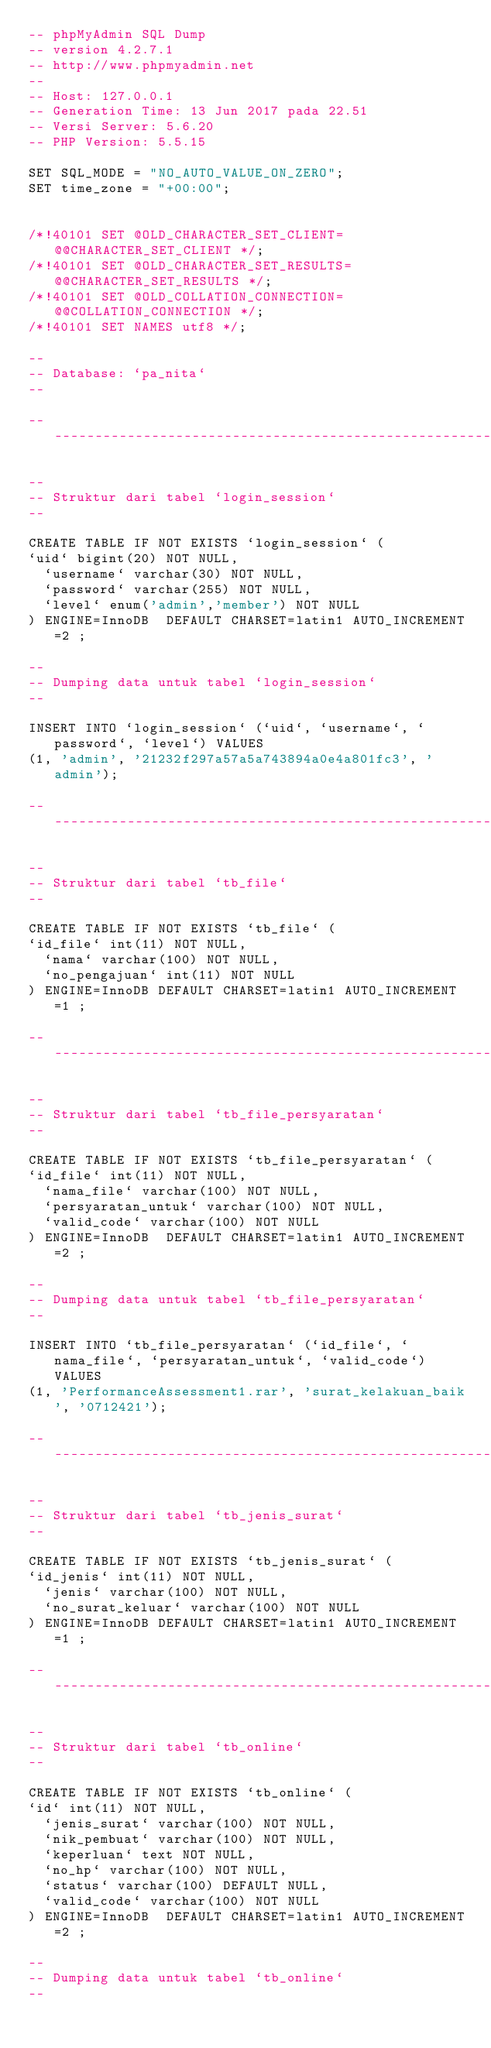Convert code to text. <code><loc_0><loc_0><loc_500><loc_500><_SQL_>-- phpMyAdmin SQL Dump
-- version 4.2.7.1
-- http://www.phpmyadmin.net
--
-- Host: 127.0.0.1
-- Generation Time: 13 Jun 2017 pada 22.51
-- Versi Server: 5.6.20
-- PHP Version: 5.5.15

SET SQL_MODE = "NO_AUTO_VALUE_ON_ZERO";
SET time_zone = "+00:00";


/*!40101 SET @OLD_CHARACTER_SET_CLIENT=@@CHARACTER_SET_CLIENT */;
/*!40101 SET @OLD_CHARACTER_SET_RESULTS=@@CHARACTER_SET_RESULTS */;
/*!40101 SET @OLD_COLLATION_CONNECTION=@@COLLATION_CONNECTION */;
/*!40101 SET NAMES utf8 */;

--
-- Database: `pa_nita`
--

-- --------------------------------------------------------

--
-- Struktur dari tabel `login_session`
--

CREATE TABLE IF NOT EXISTS `login_session` (
`uid` bigint(20) NOT NULL,
  `username` varchar(30) NOT NULL,
  `password` varchar(255) NOT NULL,
  `level` enum('admin','member') NOT NULL
) ENGINE=InnoDB  DEFAULT CHARSET=latin1 AUTO_INCREMENT=2 ;

--
-- Dumping data untuk tabel `login_session`
--

INSERT INTO `login_session` (`uid`, `username`, `password`, `level`) VALUES
(1, 'admin', '21232f297a57a5a743894a0e4a801fc3', 'admin');

-- --------------------------------------------------------

--
-- Struktur dari tabel `tb_file`
--

CREATE TABLE IF NOT EXISTS `tb_file` (
`id_file` int(11) NOT NULL,
  `nama` varchar(100) NOT NULL,
  `no_pengajuan` int(11) NOT NULL
) ENGINE=InnoDB DEFAULT CHARSET=latin1 AUTO_INCREMENT=1 ;

-- --------------------------------------------------------

--
-- Struktur dari tabel `tb_file_persyaratan`
--

CREATE TABLE IF NOT EXISTS `tb_file_persyaratan` (
`id_file` int(11) NOT NULL,
  `nama_file` varchar(100) NOT NULL,
  `persyaratan_untuk` varchar(100) NOT NULL,
  `valid_code` varchar(100) NOT NULL
) ENGINE=InnoDB  DEFAULT CHARSET=latin1 AUTO_INCREMENT=2 ;

--
-- Dumping data untuk tabel `tb_file_persyaratan`
--

INSERT INTO `tb_file_persyaratan` (`id_file`, `nama_file`, `persyaratan_untuk`, `valid_code`) VALUES
(1, 'PerformanceAssessment1.rar', 'surat_kelakuan_baik', '0712421');

-- --------------------------------------------------------

--
-- Struktur dari tabel `tb_jenis_surat`
--

CREATE TABLE IF NOT EXISTS `tb_jenis_surat` (
`id_jenis` int(11) NOT NULL,
  `jenis` varchar(100) NOT NULL,
  `no_surat_keluar` varchar(100) NOT NULL
) ENGINE=InnoDB DEFAULT CHARSET=latin1 AUTO_INCREMENT=1 ;

-- --------------------------------------------------------

--
-- Struktur dari tabel `tb_online`
--

CREATE TABLE IF NOT EXISTS `tb_online` (
`id` int(11) NOT NULL,
  `jenis_surat` varchar(100) NOT NULL,
  `nik_pembuat` varchar(100) NOT NULL,
  `keperluan` text NOT NULL,
  `no_hp` varchar(100) NOT NULL,
  `status` varchar(100) DEFAULT NULL,
  `valid_code` varchar(100) NOT NULL
) ENGINE=InnoDB  DEFAULT CHARSET=latin1 AUTO_INCREMENT=2 ;

--
-- Dumping data untuk tabel `tb_online`
--
</code> 